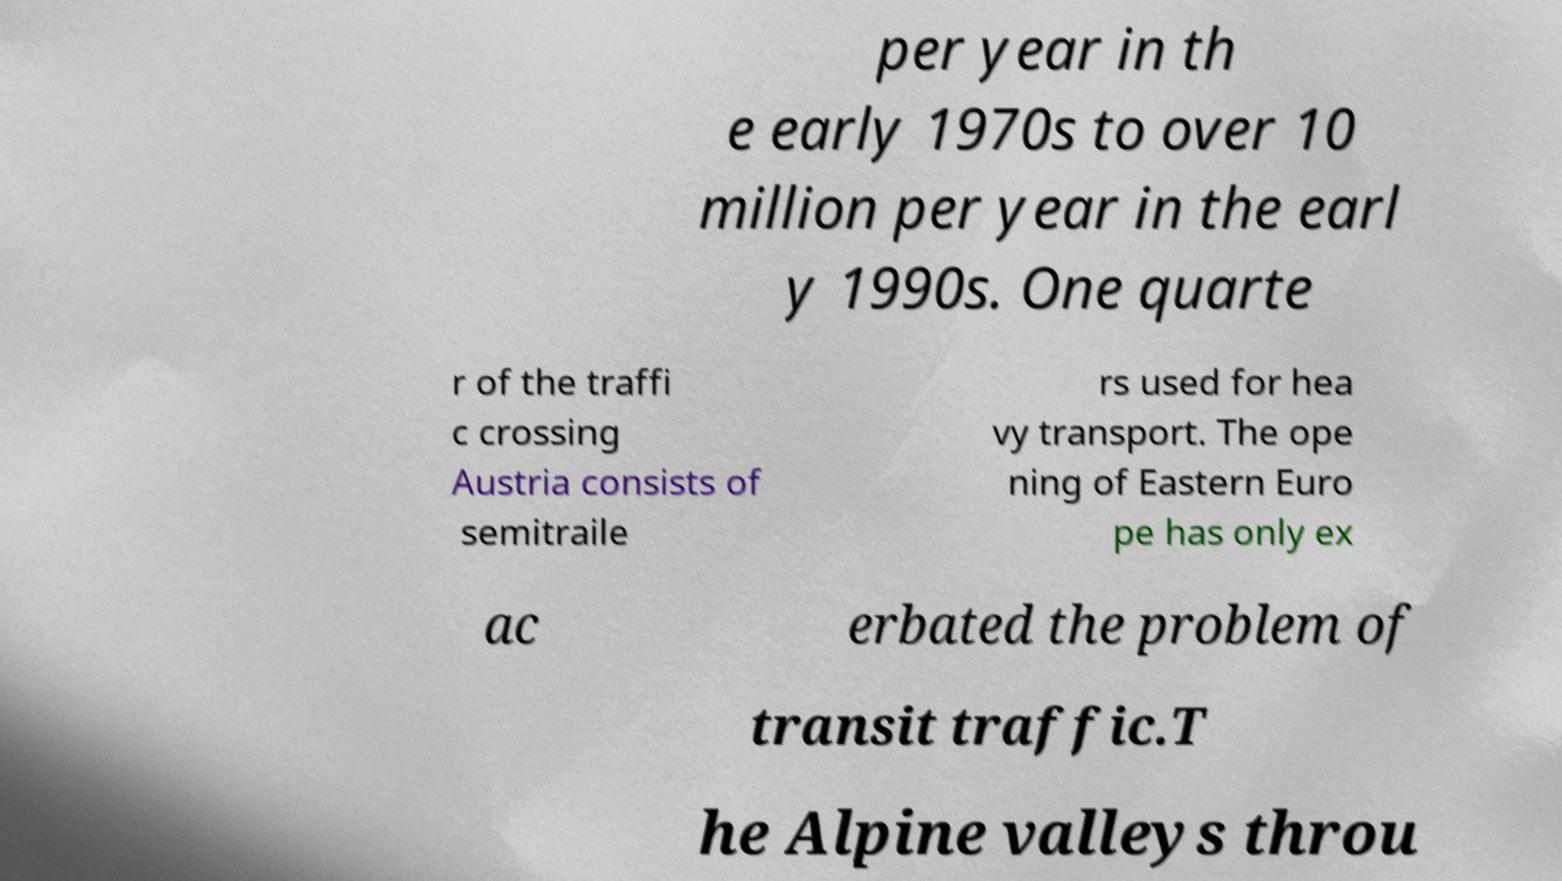Can you accurately transcribe the text from the provided image for me? per year in th e early 1970s to over 10 million per year in the earl y 1990s. One quarte r of the traffi c crossing Austria consists of semitraile rs used for hea vy transport. The ope ning of Eastern Euro pe has only ex ac erbated the problem of transit traffic.T he Alpine valleys throu 